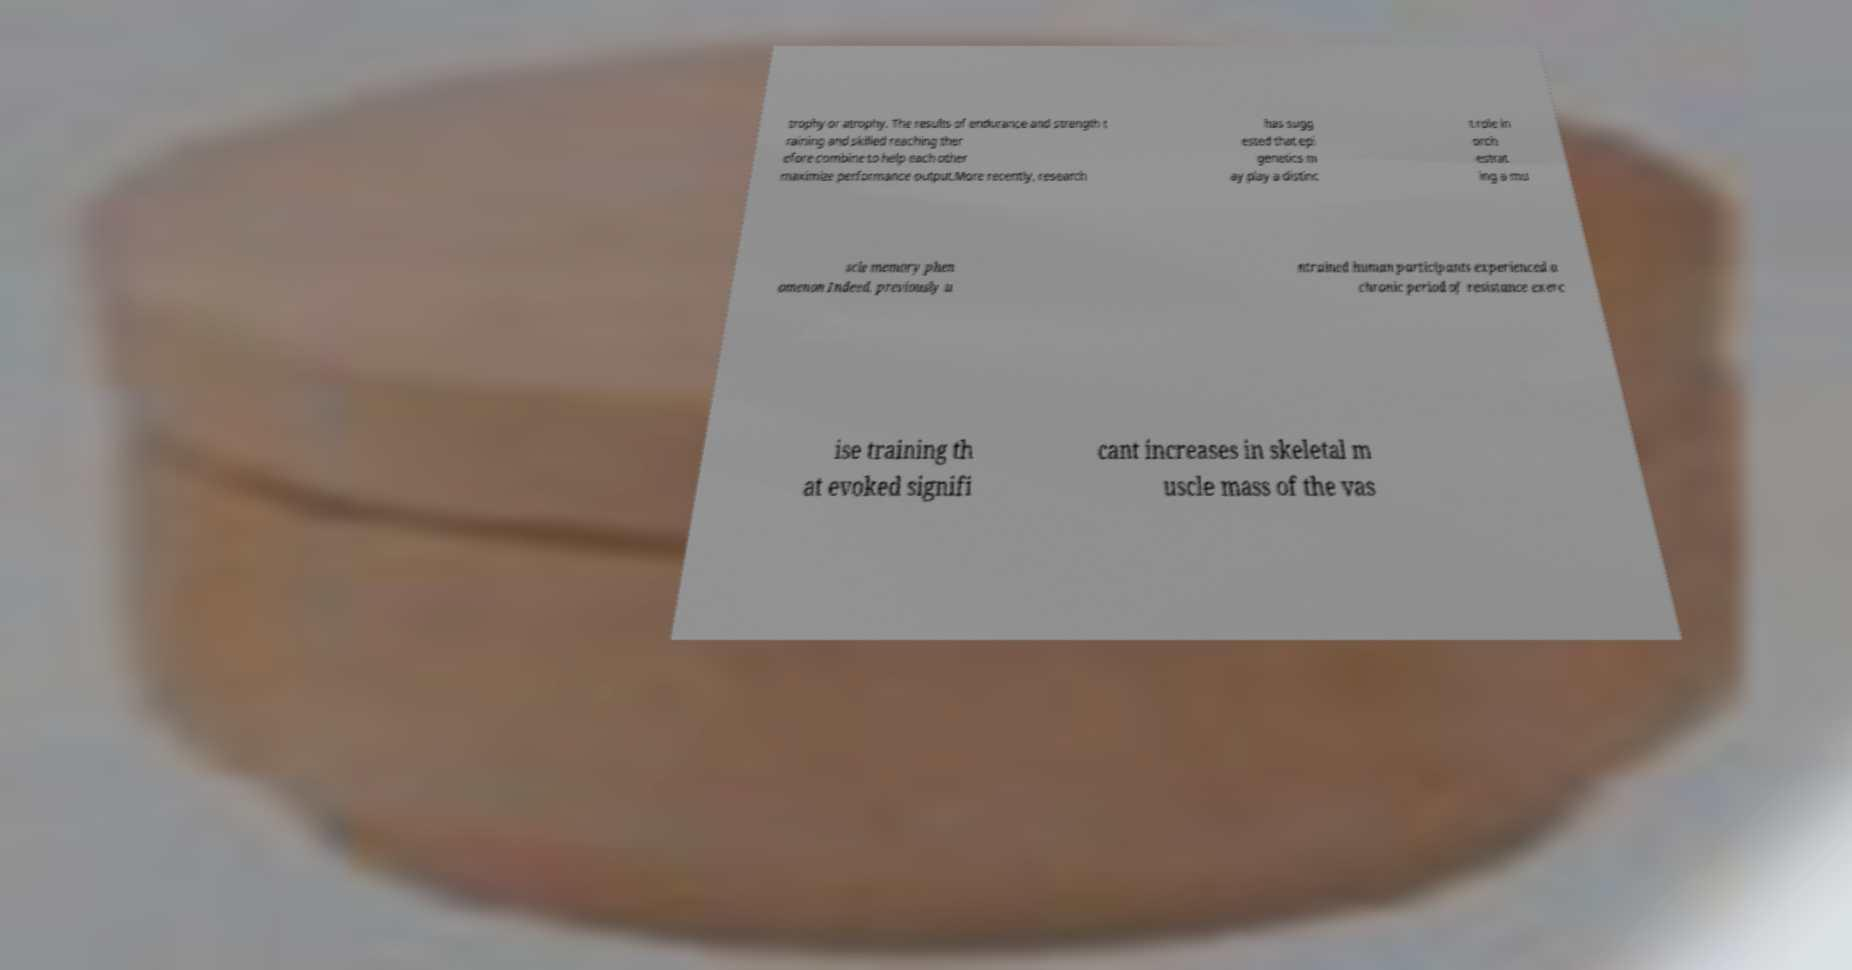Please identify and transcribe the text found in this image. trophy or atrophy. The results of endurance and strength t raining and skilled reaching ther efore combine to help each other maximize performance output.More recently, research has sugg ested that epi genetics m ay play a distinc t role in orch estrat ing a mu scle memory phen omenon Indeed, previously u ntrained human participants experienced a chronic period of resistance exerc ise training th at evoked signifi cant increases in skeletal m uscle mass of the vas 